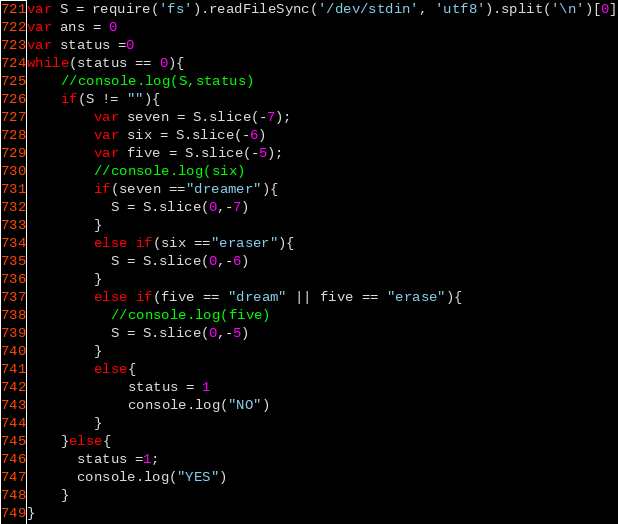<code> <loc_0><loc_0><loc_500><loc_500><_JavaScript_>var S = require('fs').readFileSync('/dev/stdin', 'utf8').split('\n')[0]
var ans = 0
var status =0
while(status == 0){
  	//console.log(S,status)
  	if(S != ""){
		var seven = S.slice(-7);
      	var six = S.slice(-6)
		var five = S.slice(-5);
      	//console.log(six)
		if(seven =="dreamer"){
	      S = S.slice(0,-7)
    	}
      	else if(six =="eraser"){
	      S = S.slice(0,-6)
    	}
		else if(five == "dream" || five == "erase"){
          //console.log(five)
	      S = S.slice(0,-5)
	    } 
  		else{
      		status = 1
      		console.log("NO")
    	}
    }else{
      status =1;
      console.log("YES")
    }
}
</code> 